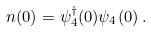<formula> <loc_0><loc_0><loc_500><loc_500>n ( 0 ) = \psi ^ { \dagger } _ { 4 } ( 0 ) \psi _ { 4 } ( 0 ) \, .</formula> 